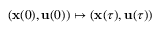<formula> <loc_0><loc_0><loc_500><loc_500>( x ( 0 ) , u ( 0 ) ) \mapsto ( x ( \tau ) , u ( \tau ) )</formula> 